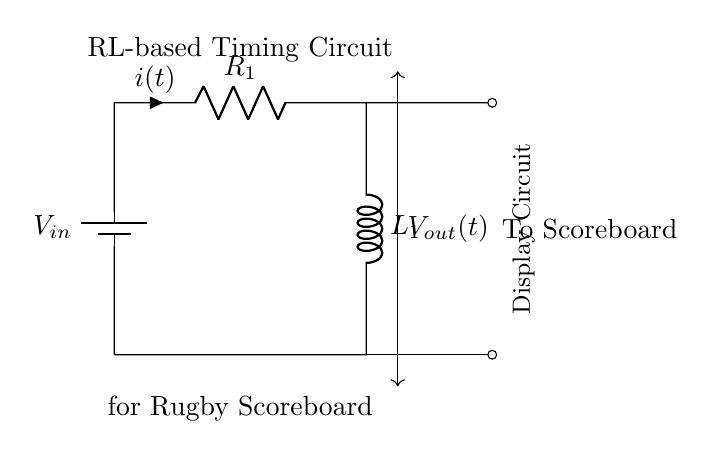What type of circuit is shown? The circuit is an RL circuit, indicated by the presence of a resistor and an inductor in series. This classification is fundamental based on the two main passive components used.
Answer: RL circuit What is the role of the battery in this circuit? The battery provides the input voltage \(V_{in}\) necessary to energize the circuit and drive the current through the resistor and inductor. This fundamental role supplies the energy needed to operate the scoreboard.
Answer: Power supply What components are connected in series in this circuit? The resistor \(R_1\) and the inductor \(L_1\) are connected in series as they share the same current path, which is essential for the behavior of an RL circuit.
Answer: Resistor and Inductor What does \(V_{out}(t)\) represent? \(V_{out}(t)\) represents the output voltage across the inductor as a function of time, which is crucial for timing applications in this scoreboard context where the display updates based on the RL time constant.
Answer: Output voltage How does the RL circuit affect the timing for the scoreboard? The RL circuit creates a time constant \( \tau = \frac{L_1}{R_1} \), determining how quickly the circuit responds to changes. This affects how fast or slow the scoreboard updates during a match, critical for timing in sports events.
Answer: Determine update timing What is the relationship between resistance and inductor size in timing? Increasing the resistance \(R_1\) results in a longer time constant \( \tau \), slowing down the voltage change, while increasing the inductance \(L_1\) also increases the time constant, affecting timing measurements.
Answer: Longer time constant 